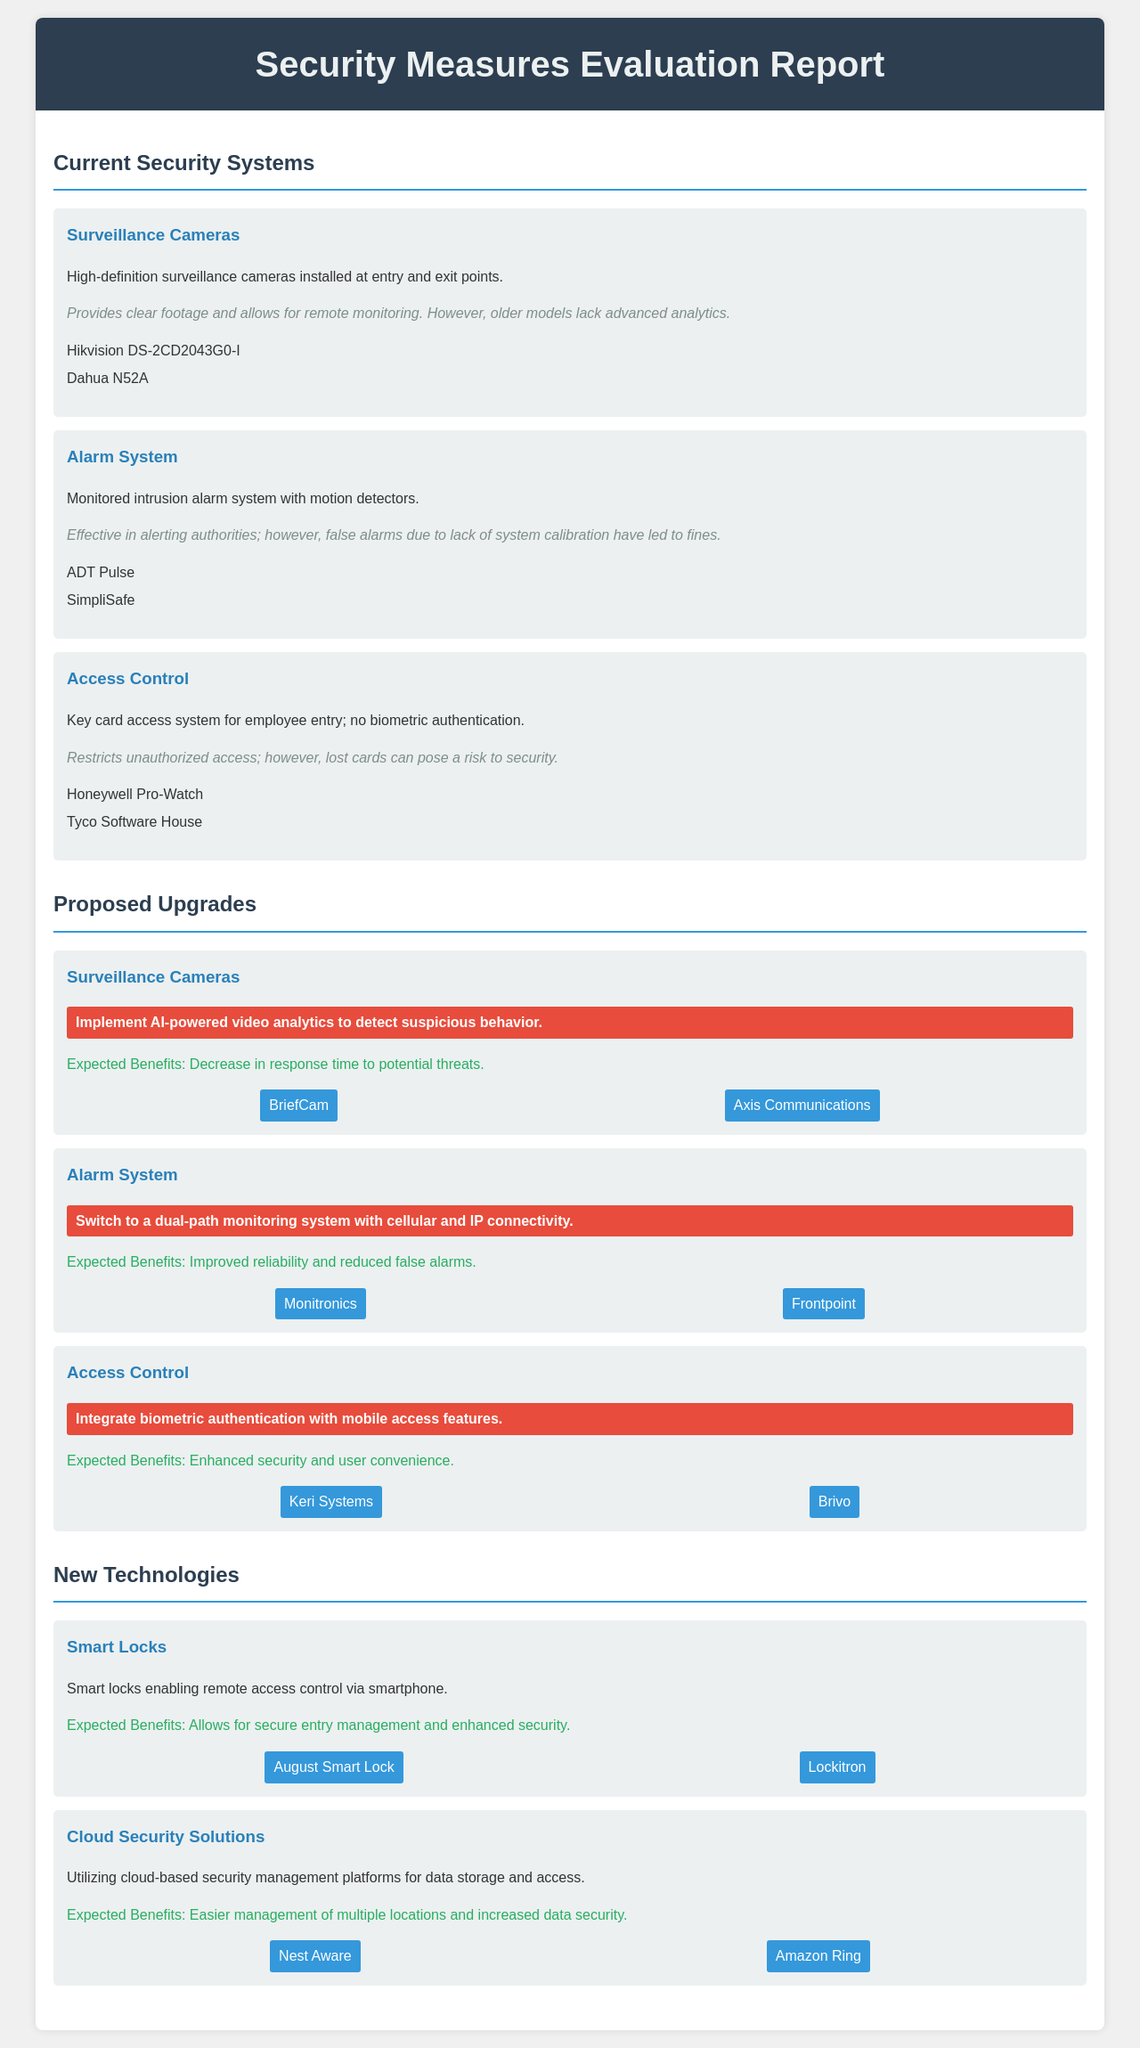What types of current security systems are listed? The document lists three types of current security systems: Surveillance Cameras, Alarm System, and Access Control.
Answer: Surveillance Cameras, Alarm System, Access Control What is one proposed upgrade for the surveillance cameras? The document states that a proposed upgrade for the surveillance cameras is to implement AI-powered video analytics.
Answer: AI-powered video analytics What is the effectiveness of the alarm system? The effectiveness of the alarm system is described as effective in alerting authorities, but has issues with false alarms due to lack of system calibration.
Answer: Effective in alerting authorities; false alarms What is the expected benefit of integrating biometric authentication in access control? The expected benefit of integrating biometric authentication is enhanced security and user convenience.
Answer: Enhanced security and user convenience Name a vendor for the proposed smart locks. The document lists August Smart Lock as a vendor for the proposed smart locks.
Answer: August Smart Lock What is one new technology mentioned in the report? The report mentions Smart Locks as one new technology.
Answer: Smart Locks What problem arises from lost cards in the access control system? The problem arising from lost cards is that they can pose a risk to security.
Answer: Risk to security How many vendors are listed for the new cloud security solutions? There are two vendors listed for the new cloud security solutions in the document.
Answer: Two vendors What monitoring system is proposed for the alarm system? The proposed monitoring system for the alarm system is a dual-path monitoring system with cellular and IP connectivity.
Answer: Dual-path monitoring system 